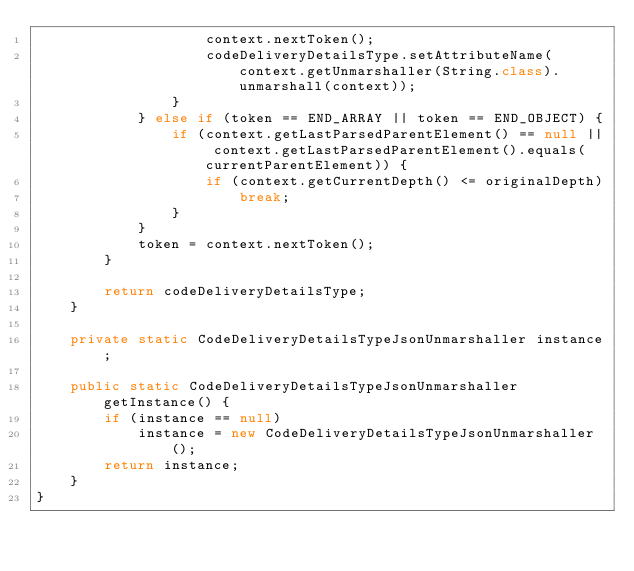Convert code to text. <code><loc_0><loc_0><loc_500><loc_500><_Java_>                    context.nextToken();
                    codeDeliveryDetailsType.setAttributeName(context.getUnmarshaller(String.class).unmarshall(context));
                }
            } else if (token == END_ARRAY || token == END_OBJECT) {
                if (context.getLastParsedParentElement() == null || context.getLastParsedParentElement().equals(currentParentElement)) {
                    if (context.getCurrentDepth() <= originalDepth)
                        break;
                }
            }
            token = context.nextToken();
        }

        return codeDeliveryDetailsType;
    }

    private static CodeDeliveryDetailsTypeJsonUnmarshaller instance;

    public static CodeDeliveryDetailsTypeJsonUnmarshaller getInstance() {
        if (instance == null)
            instance = new CodeDeliveryDetailsTypeJsonUnmarshaller();
        return instance;
    }
}
</code> 